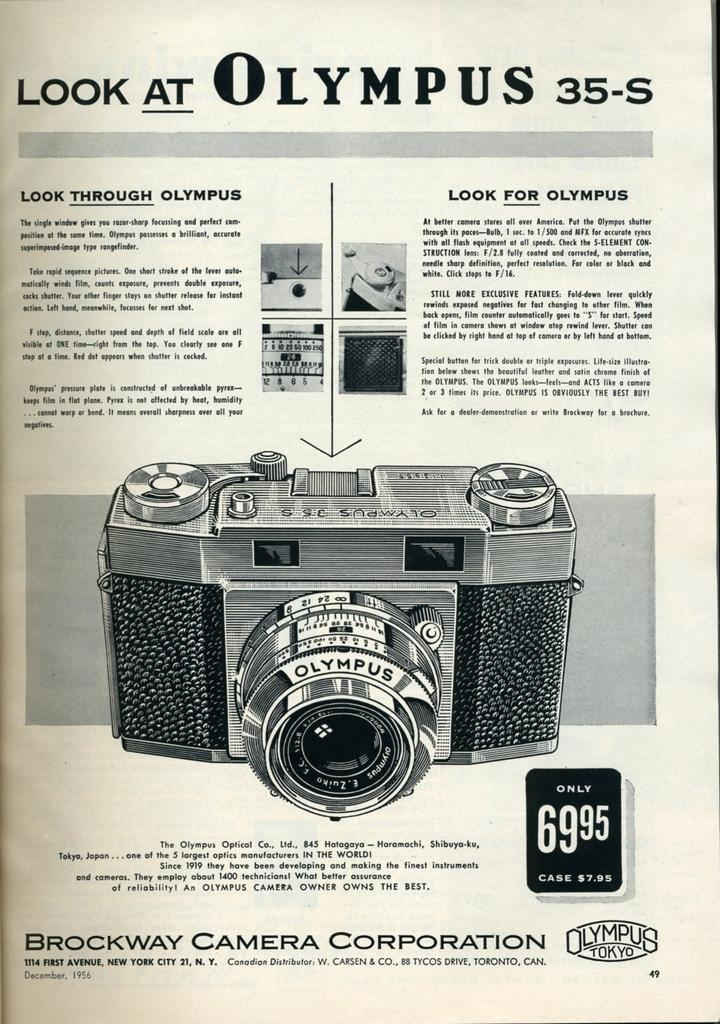What is the main subject of the image? The main subject of the image is a paper. What can be seen in the center of the paper? There is a camera in the center of the image. What else is visible in the image besides the camera? There is text visible in the background of the image. Can you tell me how many goats are visible in the image? There are no goats present in the image; it features a paper with a camera and text. What is the stomach's role in the image? There is no stomach present in the image, as it is a picture of a paper with a camera and text. 